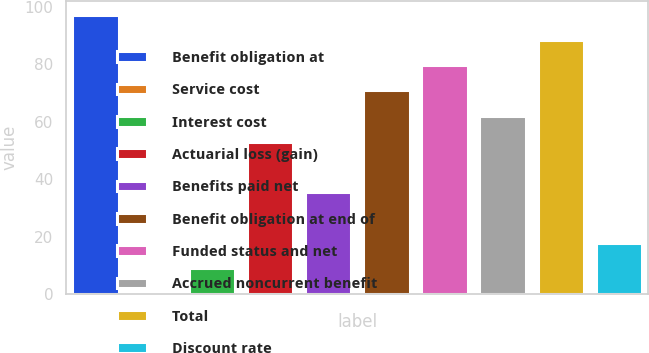<chart> <loc_0><loc_0><loc_500><loc_500><bar_chart><fcel>Benefit obligation at<fcel>Service cost<fcel>Interest cost<fcel>Actuarial loss (gain)<fcel>Benefits paid net<fcel>Benefit obligation at end of<fcel>Funded status and net<fcel>Accrued noncurrent benefit<fcel>Total<fcel>Discount rate<nl><fcel>97.22<fcel>0.3<fcel>9.08<fcel>52.98<fcel>35.42<fcel>70.88<fcel>79.66<fcel>62.1<fcel>88.44<fcel>17.86<nl></chart> 